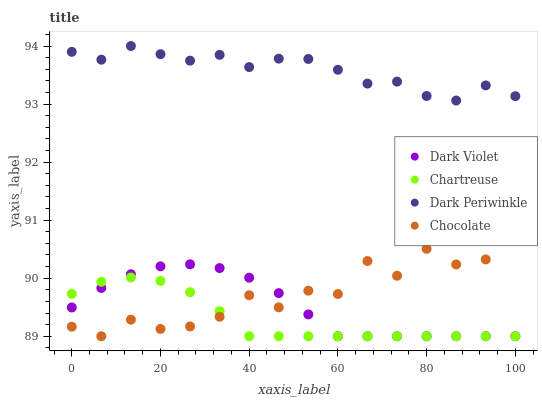Does Chartreuse have the minimum area under the curve?
Answer yes or no. Yes. Does Dark Periwinkle have the maximum area under the curve?
Answer yes or no. Yes. Does Dark Violet have the minimum area under the curve?
Answer yes or no. No. Does Dark Violet have the maximum area under the curve?
Answer yes or no. No. Is Chartreuse the smoothest?
Answer yes or no. Yes. Is Chocolate the roughest?
Answer yes or no. Yes. Is Dark Periwinkle the smoothest?
Answer yes or no. No. Is Dark Periwinkle the roughest?
Answer yes or no. No. Does Chartreuse have the lowest value?
Answer yes or no. Yes. Does Dark Periwinkle have the lowest value?
Answer yes or no. No. Does Dark Periwinkle have the highest value?
Answer yes or no. Yes. Does Dark Violet have the highest value?
Answer yes or no. No. Is Chocolate less than Dark Periwinkle?
Answer yes or no. Yes. Is Dark Periwinkle greater than Dark Violet?
Answer yes or no. Yes. Does Dark Violet intersect Chocolate?
Answer yes or no. Yes. Is Dark Violet less than Chocolate?
Answer yes or no. No. Is Dark Violet greater than Chocolate?
Answer yes or no. No. Does Chocolate intersect Dark Periwinkle?
Answer yes or no. No. 